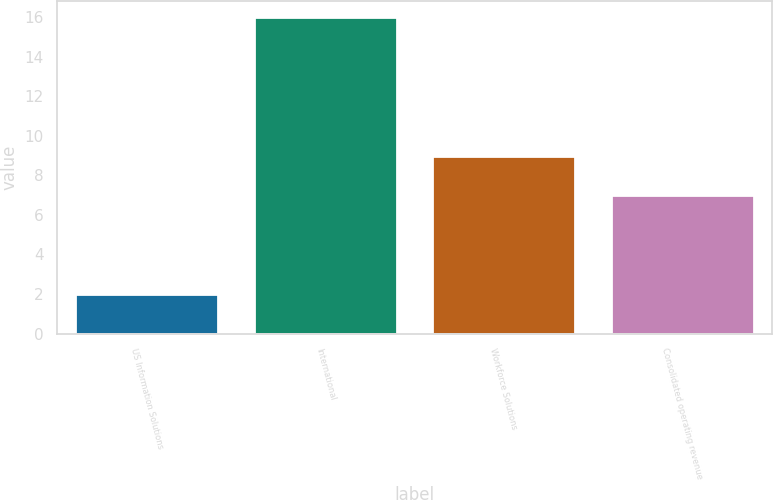<chart> <loc_0><loc_0><loc_500><loc_500><bar_chart><fcel>US Information Solutions<fcel>International<fcel>Workforce Solutions<fcel>Consolidated operating revenue<nl><fcel>2<fcel>16<fcel>9<fcel>7<nl></chart> 